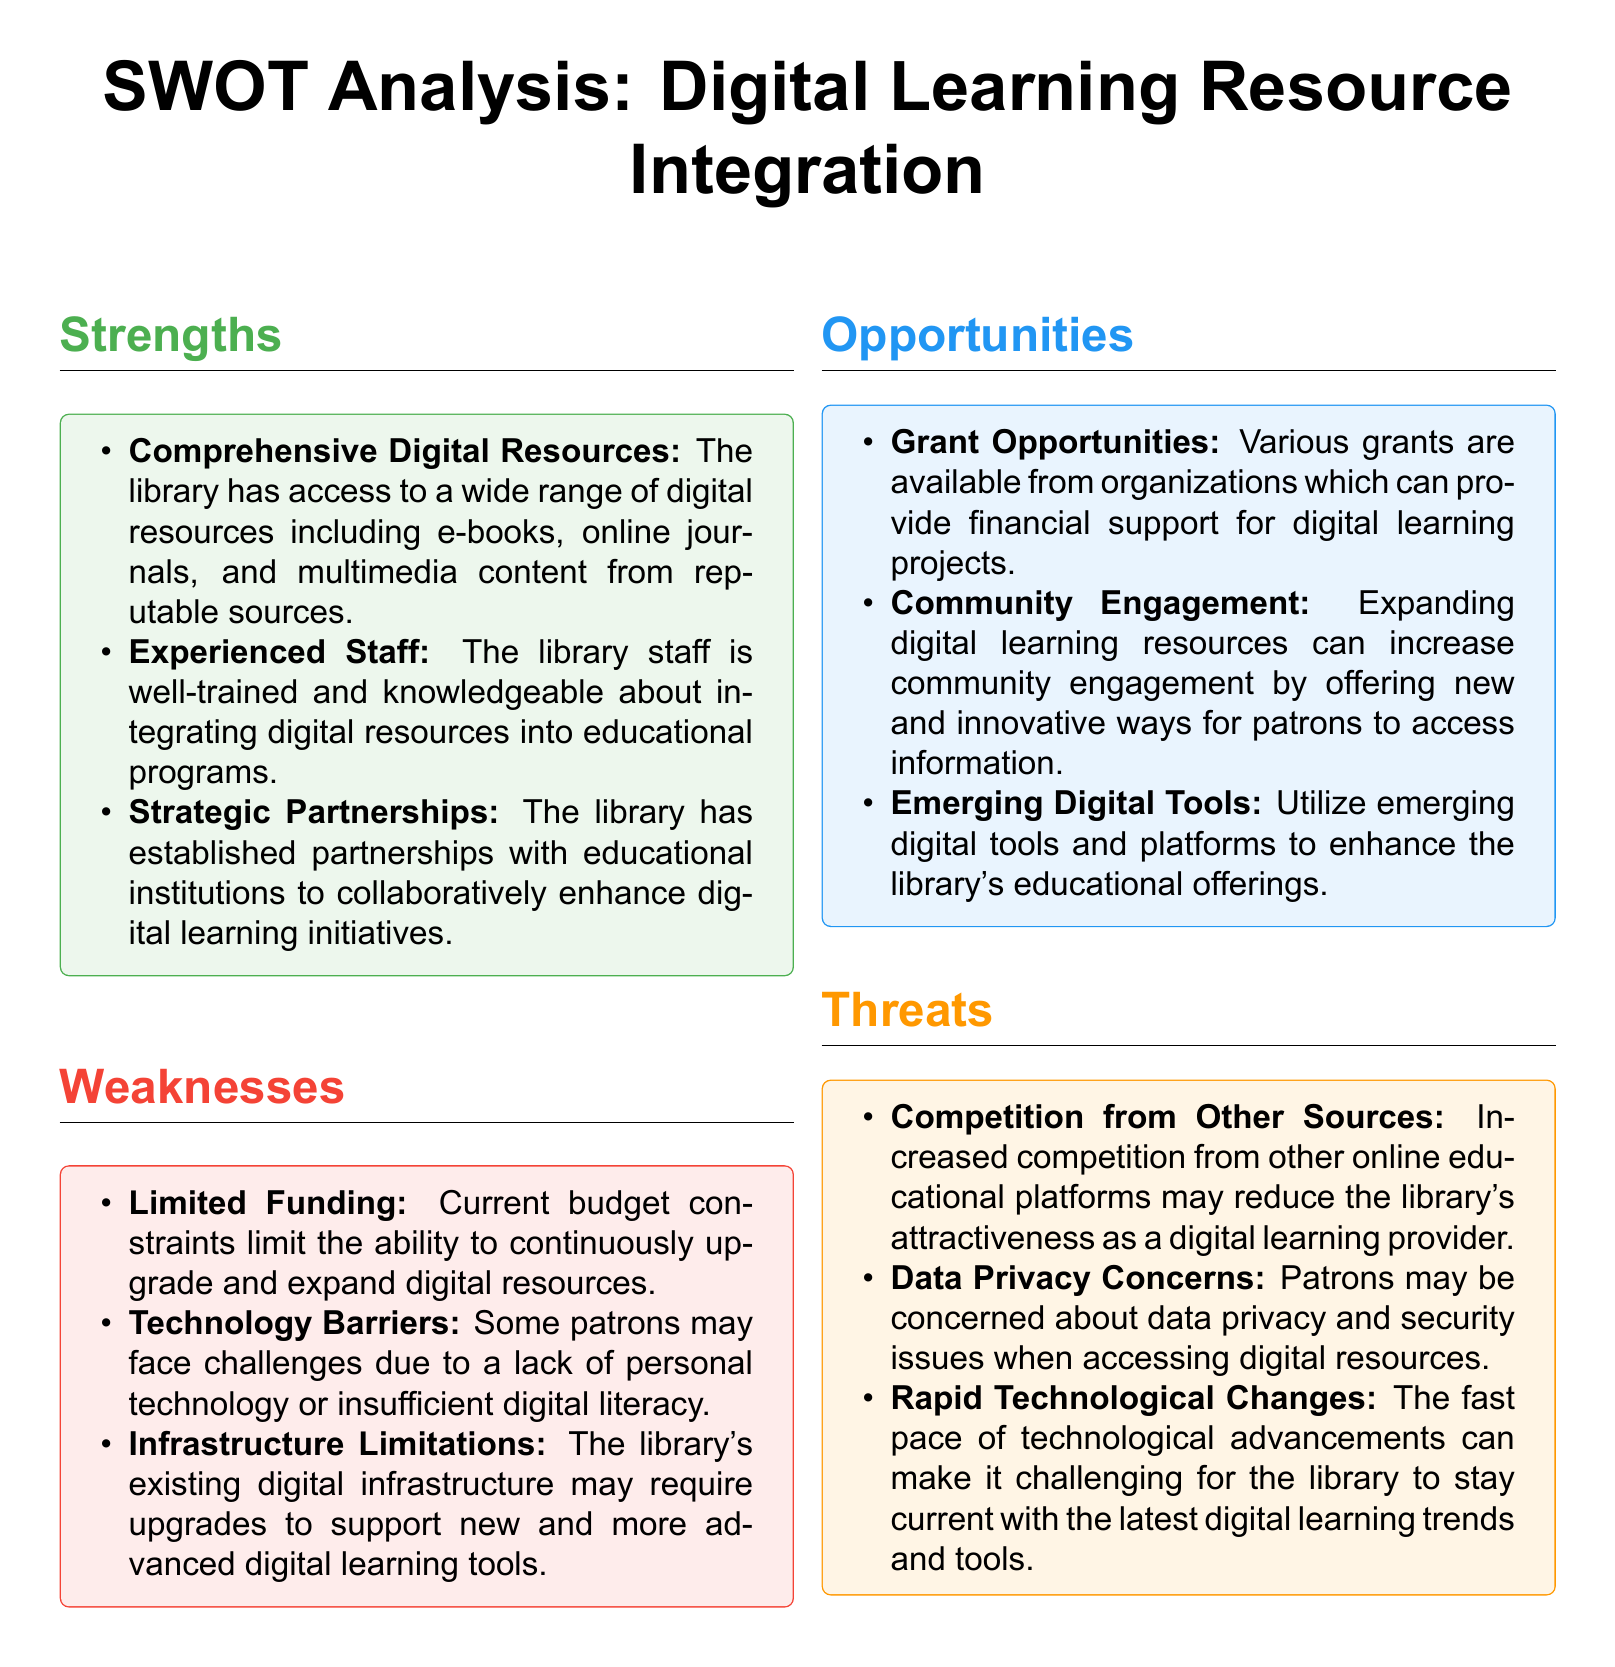What are the strengths mentioned in the document? The strengths are listed in the "Strengths" section of the SWOT analysis, which includes "Comprehensive Digital Resources," "Experienced Staff," and "Strategic Partnerships."
Answer: Comprehensive Digital Resources, Experienced Staff, Strategic Partnerships What is the primary weakness related to funding? The document states that "Limited Funding" is a weakness affecting the library's ability to upgrade digital resources.
Answer: Limited Funding How many opportunities are identified in the document? The document lists three opportunities in the "Opportunities" section, specifically "Grant Opportunities," "Community Engagement," and "Emerging Digital Tools."
Answer: Three What threat relates to competition? The document mentions "Competition from Other Sources" as a threat affecting the library's attractiveness as a digital learning provider.
Answer: Competition from Other Sources What emerging aspect does the opportunities section highlight? The opportunities section highlights "Emerging Digital Tools" as a way to enhance educational offerings.
Answer: Emerging Digital Tools Which section discusses the library's partnerships? The partnerships are discussed under the "Strengths" section, emphasizing the strategic collaborations with educational institutions.
Answer: Strengths What is one technology-related weakness mentioned? The document points out "Technology Barriers" as a weakness impacting patrons' access to digital learning resources.
Answer: Technology Barriers What does the document indicate about data privacy? The document mentions "Data Privacy Concerns" as a threat regarding patron security when accessing digital resources.
Answer: Data Privacy Concerns How is the library staff described in terms of experience? The document describes the library staff as "well-trained and knowledgeable" regarding digital resource integration.
Answer: well-trained and knowledgeable 